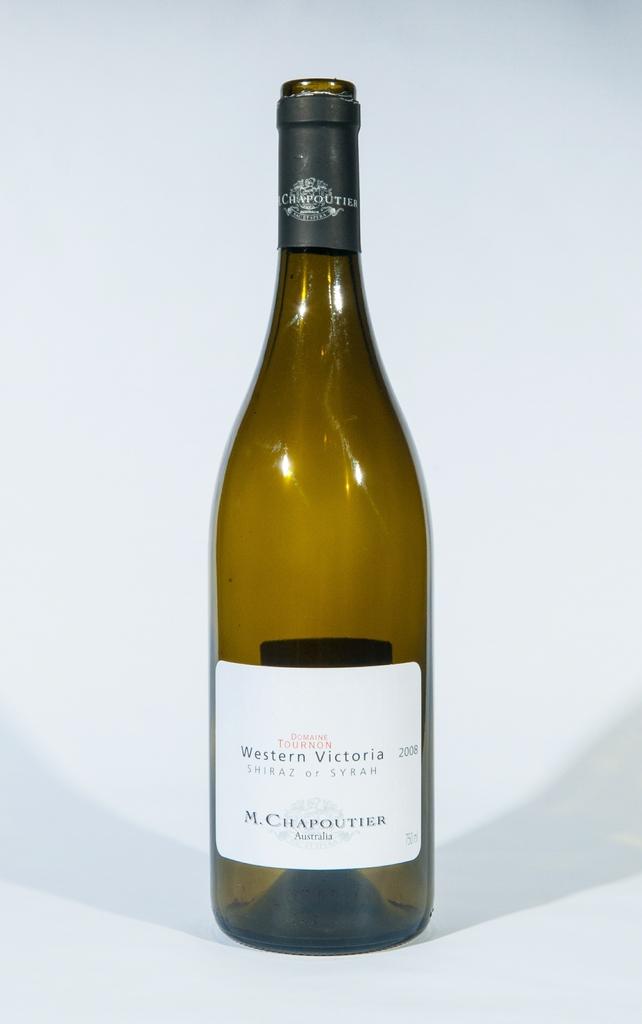What winery is this bottle from?
Ensure brevity in your answer.  Western victoria. What year was this wine produced?
Your response must be concise. 2008. 